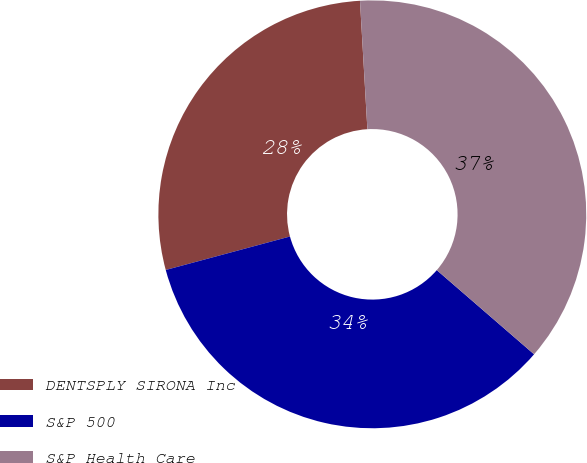Convert chart. <chart><loc_0><loc_0><loc_500><loc_500><pie_chart><fcel>DENTSPLY SIRONA Inc<fcel>S&P 500<fcel>S&P Health Care<nl><fcel>28.27%<fcel>34.46%<fcel>37.27%<nl></chart> 